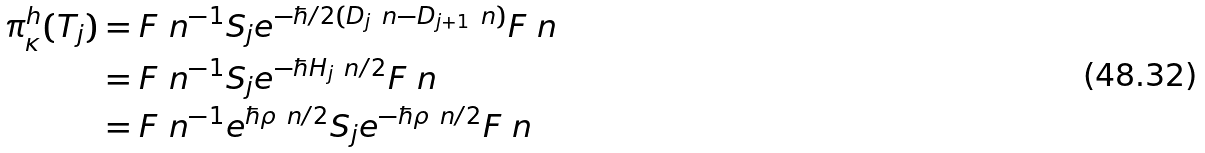<formula> <loc_0><loc_0><loc_500><loc_500>\pi _ { \kappa } ^ { h } ( T _ { j } ) & = { F \ n } ^ { - 1 } S _ { j } e ^ { - \hbar { / } 2 ( D _ { j } \ n - D _ { j + 1 } \ n ) } { F \ n } \\ & = { F \ n } ^ { - 1 } S _ { j } e ^ { - \hbar { H } _ { j } \ n / 2 } { F \ n } \\ & = { F \ n } ^ { - 1 } e ^ { \hbar { \rho } \ n / 2 } S _ { j } e ^ { - \hbar { \rho } \ n / 2 } { F \ n }</formula> 